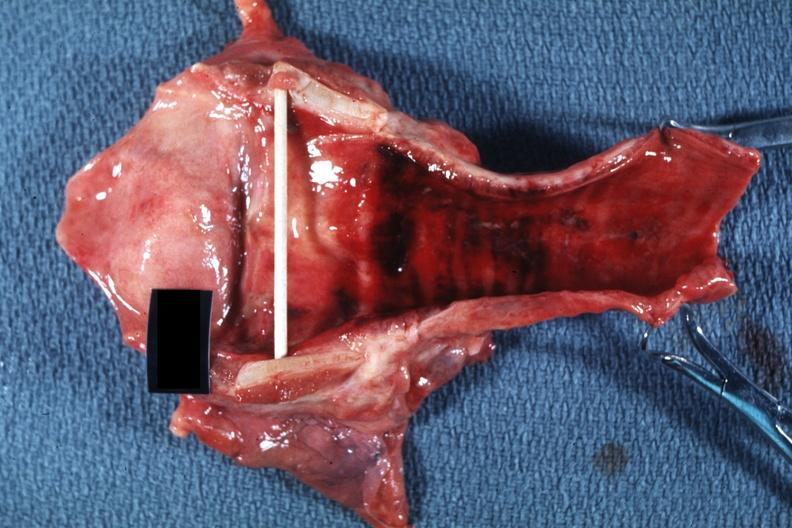what is present?
Answer the question using a single word or phrase. Larynx 